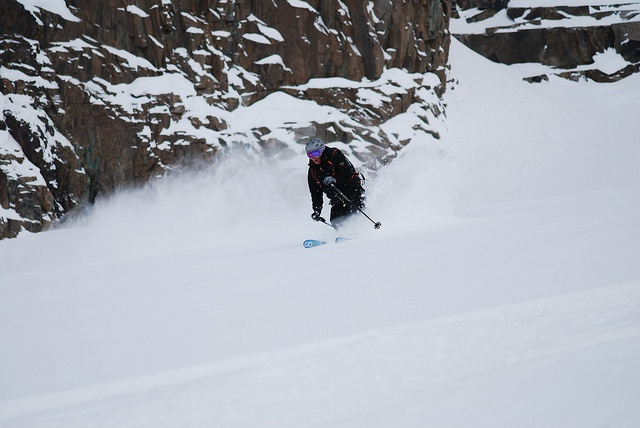Describe the objects in this image and their specific colors. I can see people in black, gray, lightgray, and darkgray tones, skis in black, lightblue, gray, and lightgray tones, and backpack in black, lightgray, gray, and darkgray tones in this image. 